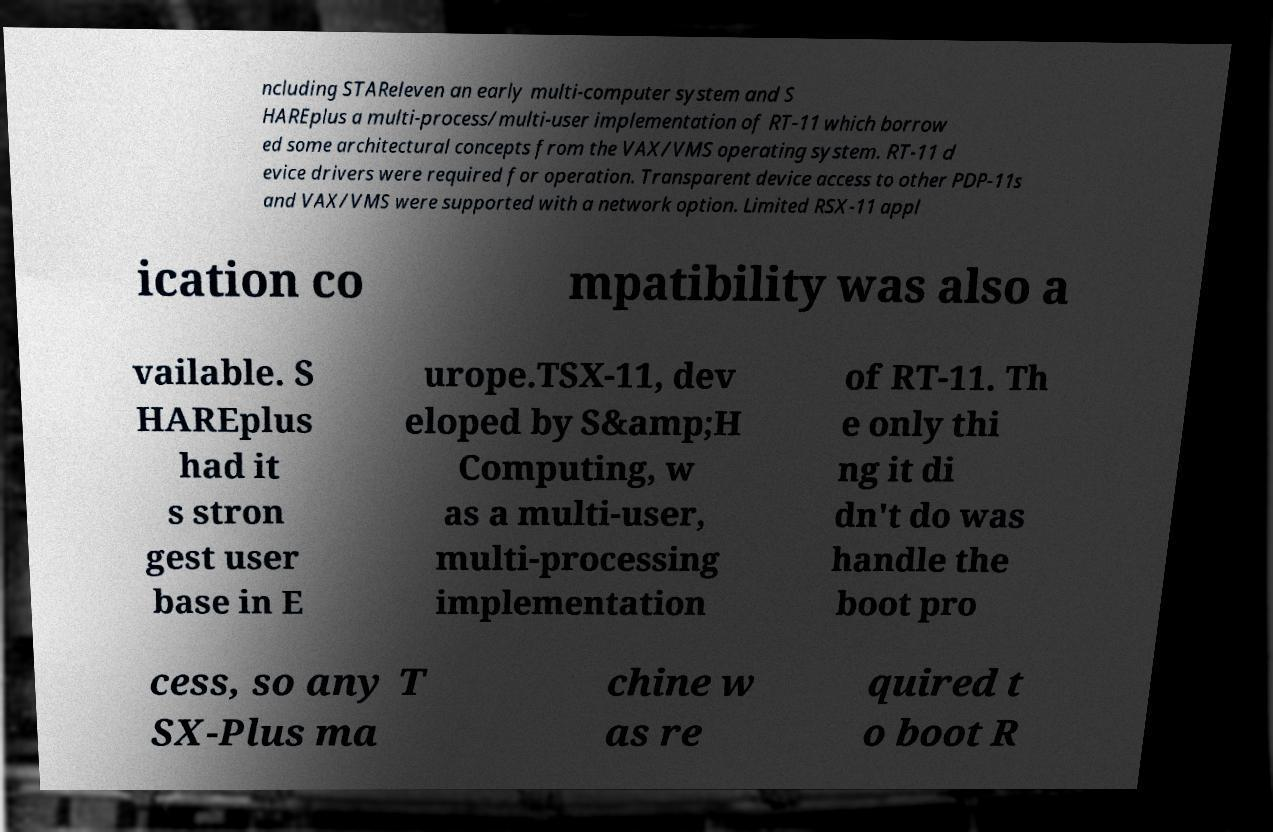Can you accurately transcribe the text from the provided image for me? ncluding STAReleven an early multi-computer system and S HAREplus a multi-process/multi-user implementation of RT-11 which borrow ed some architectural concepts from the VAX/VMS operating system. RT-11 d evice drivers were required for operation. Transparent device access to other PDP-11s and VAX/VMS were supported with a network option. Limited RSX-11 appl ication co mpatibility was also a vailable. S HAREplus had it s stron gest user base in E urope.TSX-11, dev eloped by S&amp;H Computing, w as a multi-user, multi-processing implementation of RT-11. Th e only thi ng it di dn't do was handle the boot pro cess, so any T SX-Plus ma chine w as re quired t o boot R 